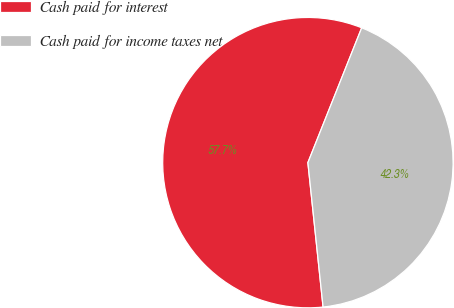<chart> <loc_0><loc_0><loc_500><loc_500><pie_chart><fcel>Cash paid for interest<fcel>Cash paid for income taxes net<nl><fcel>57.71%<fcel>42.29%<nl></chart> 